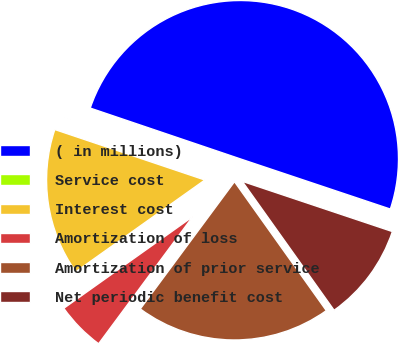<chart> <loc_0><loc_0><loc_500><loc_500><pie_chart><fcel>( in millions)<fcel>Service cost<fcel>Interest cost<fcel>Amortization of loss<fcel>Amortization of prior service<fcel>Net periodic benefit cost<nl><fcel>49.94%<fcel>0.03%<fcel>15.0%<fcel>5.02%<fcel>19.99%<fcel>10.01%<nl></chart> 